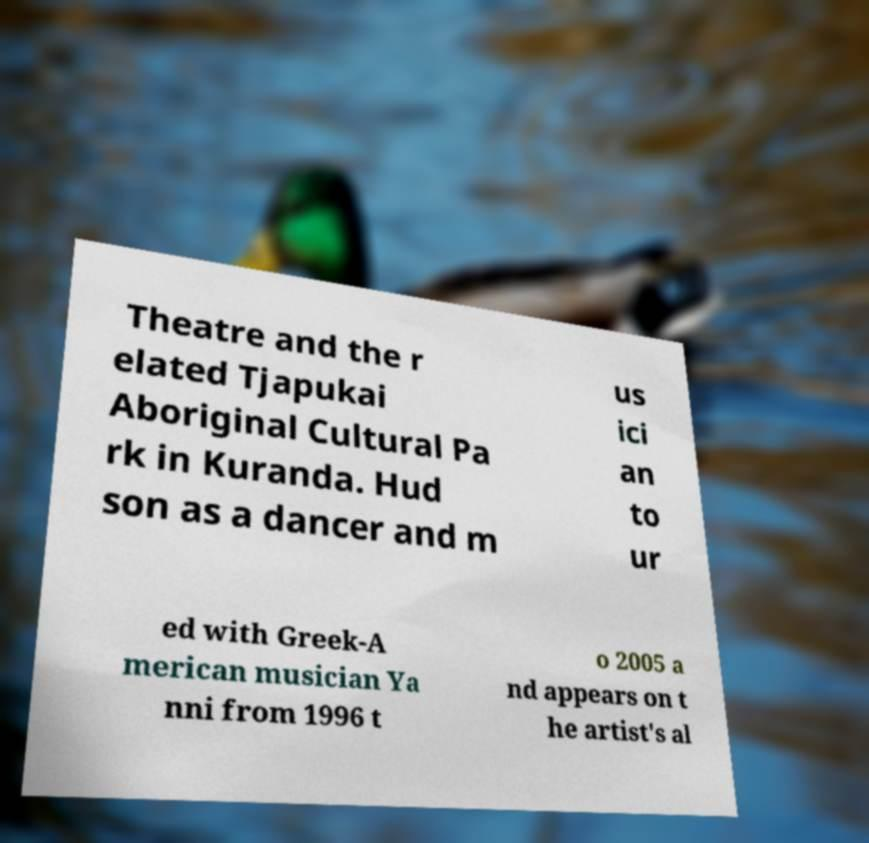Please read and relay the text visible in this image. What does it say? Theatre and the r elated Tjapukai Aboriginal Cultural Pa rk in Kuranda. Hud son as a dancer and m us ici an to ur ed with Greek-A merican musician Ya nni from 1996 t o 2005 a nd appears on t he artist's al 